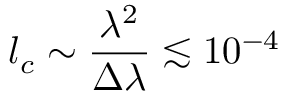Convert formula to latex. <formula><loc_0><loc_0><loc_500><loc_500>l _ { c } \sim \frac { \lambda ^ { 2 } } { \Delta \lambda } \lesssim 1 0 ^ { - 4 }</formula> 